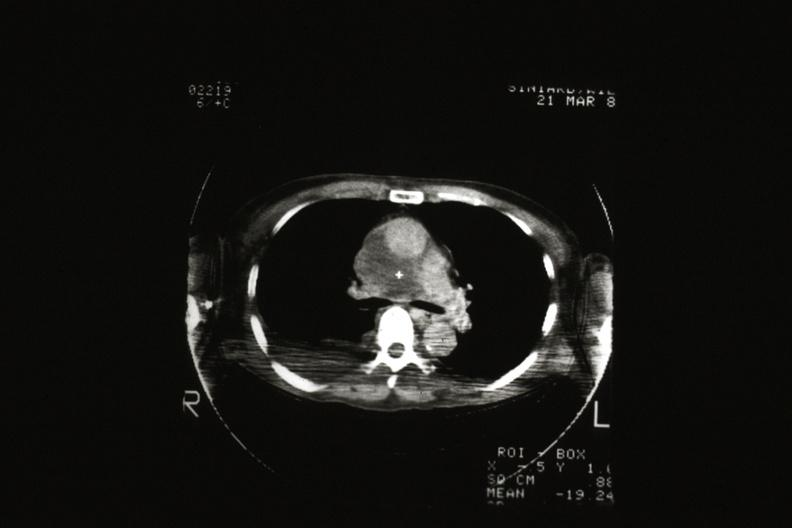s hematologic present?
Answer the question using a single word or phrase. Yes 